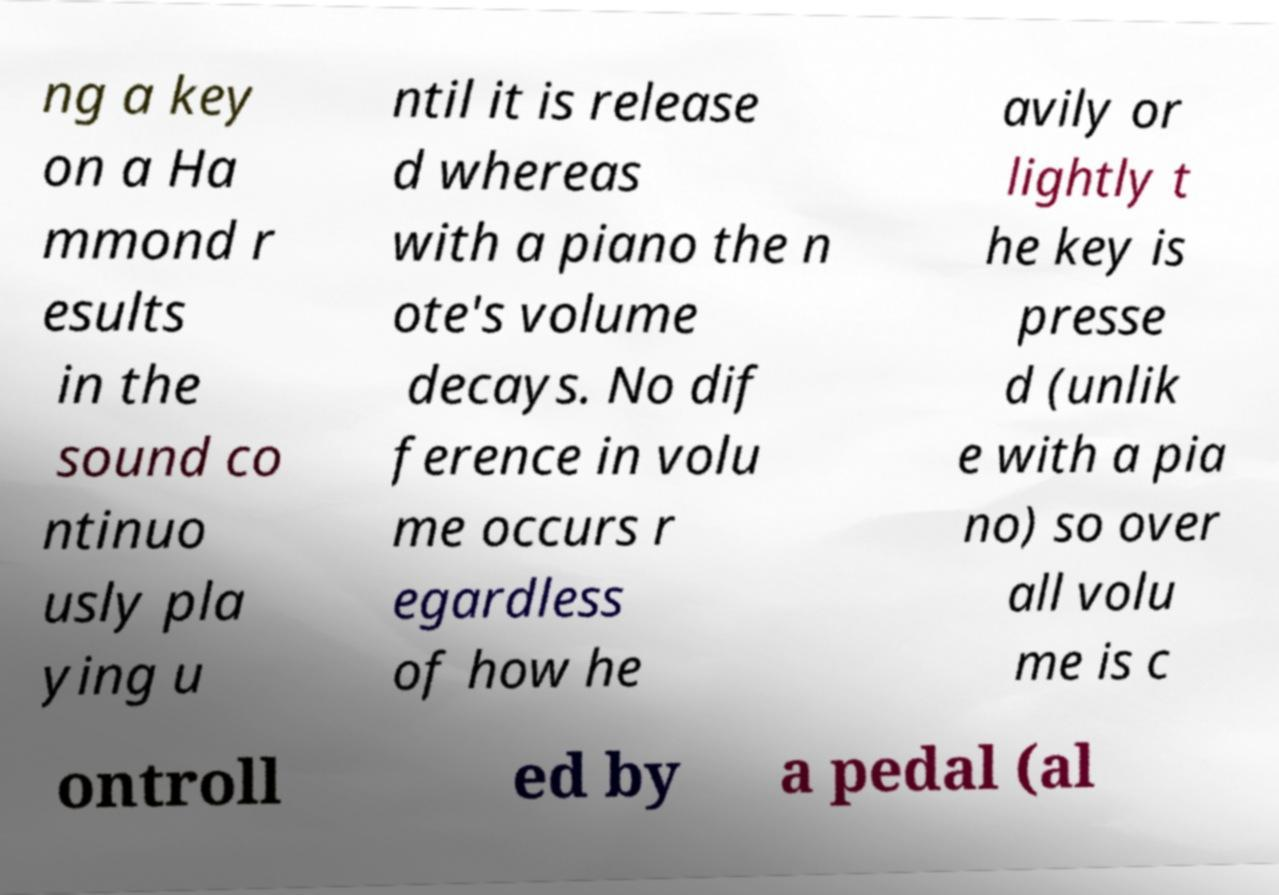I need the written content from this picture converted into text. Can you do that? ng a key on a Ha mmond r esults in the sound co ntinuo usly pla ying u ntil it is release d whereas with a piano the n ote's volume decays. No dif ference in volu me occurs r egardless of how he avily or lightly t he key is presse d (unlik e with a pia no) so over all volu me is c ontroll ed by a pedal (al 